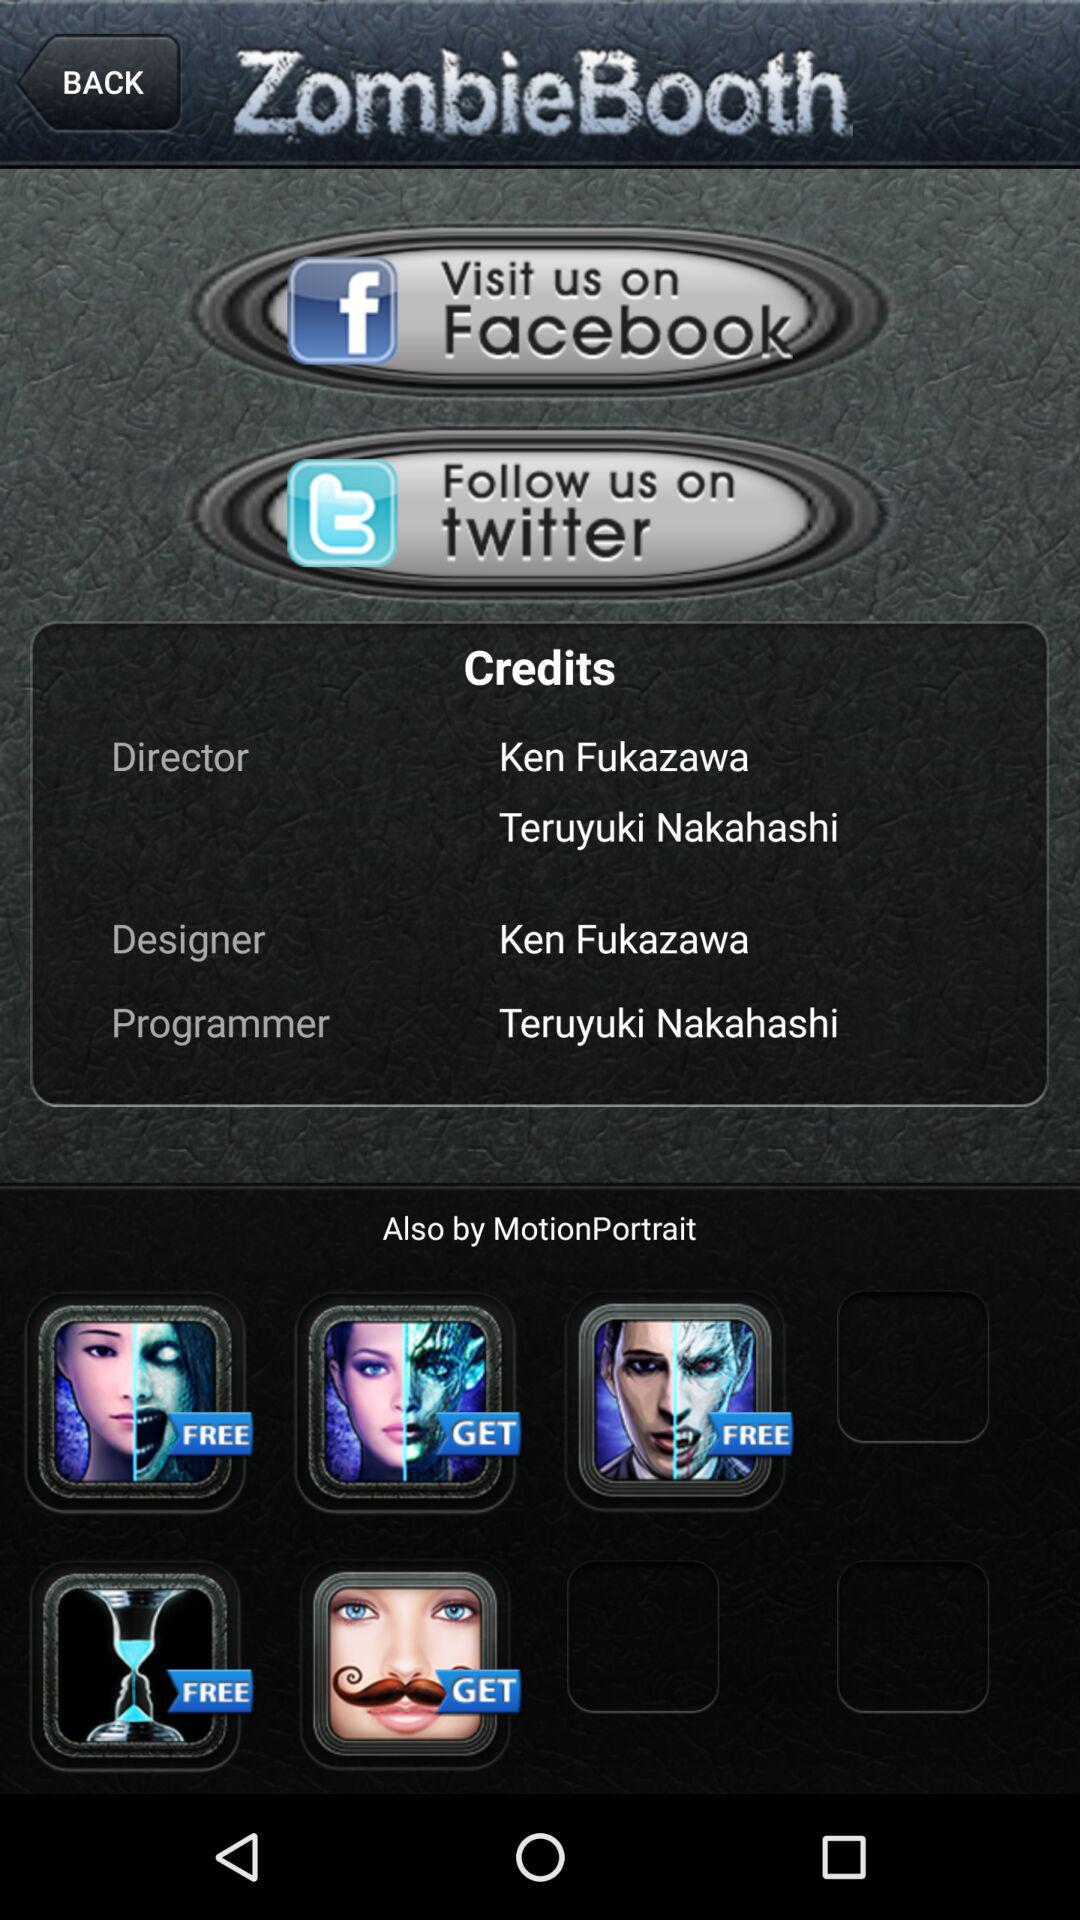What is the name of the director? The names of the directors are Ken Fukazawa and Teruyuki Nakahashi. 